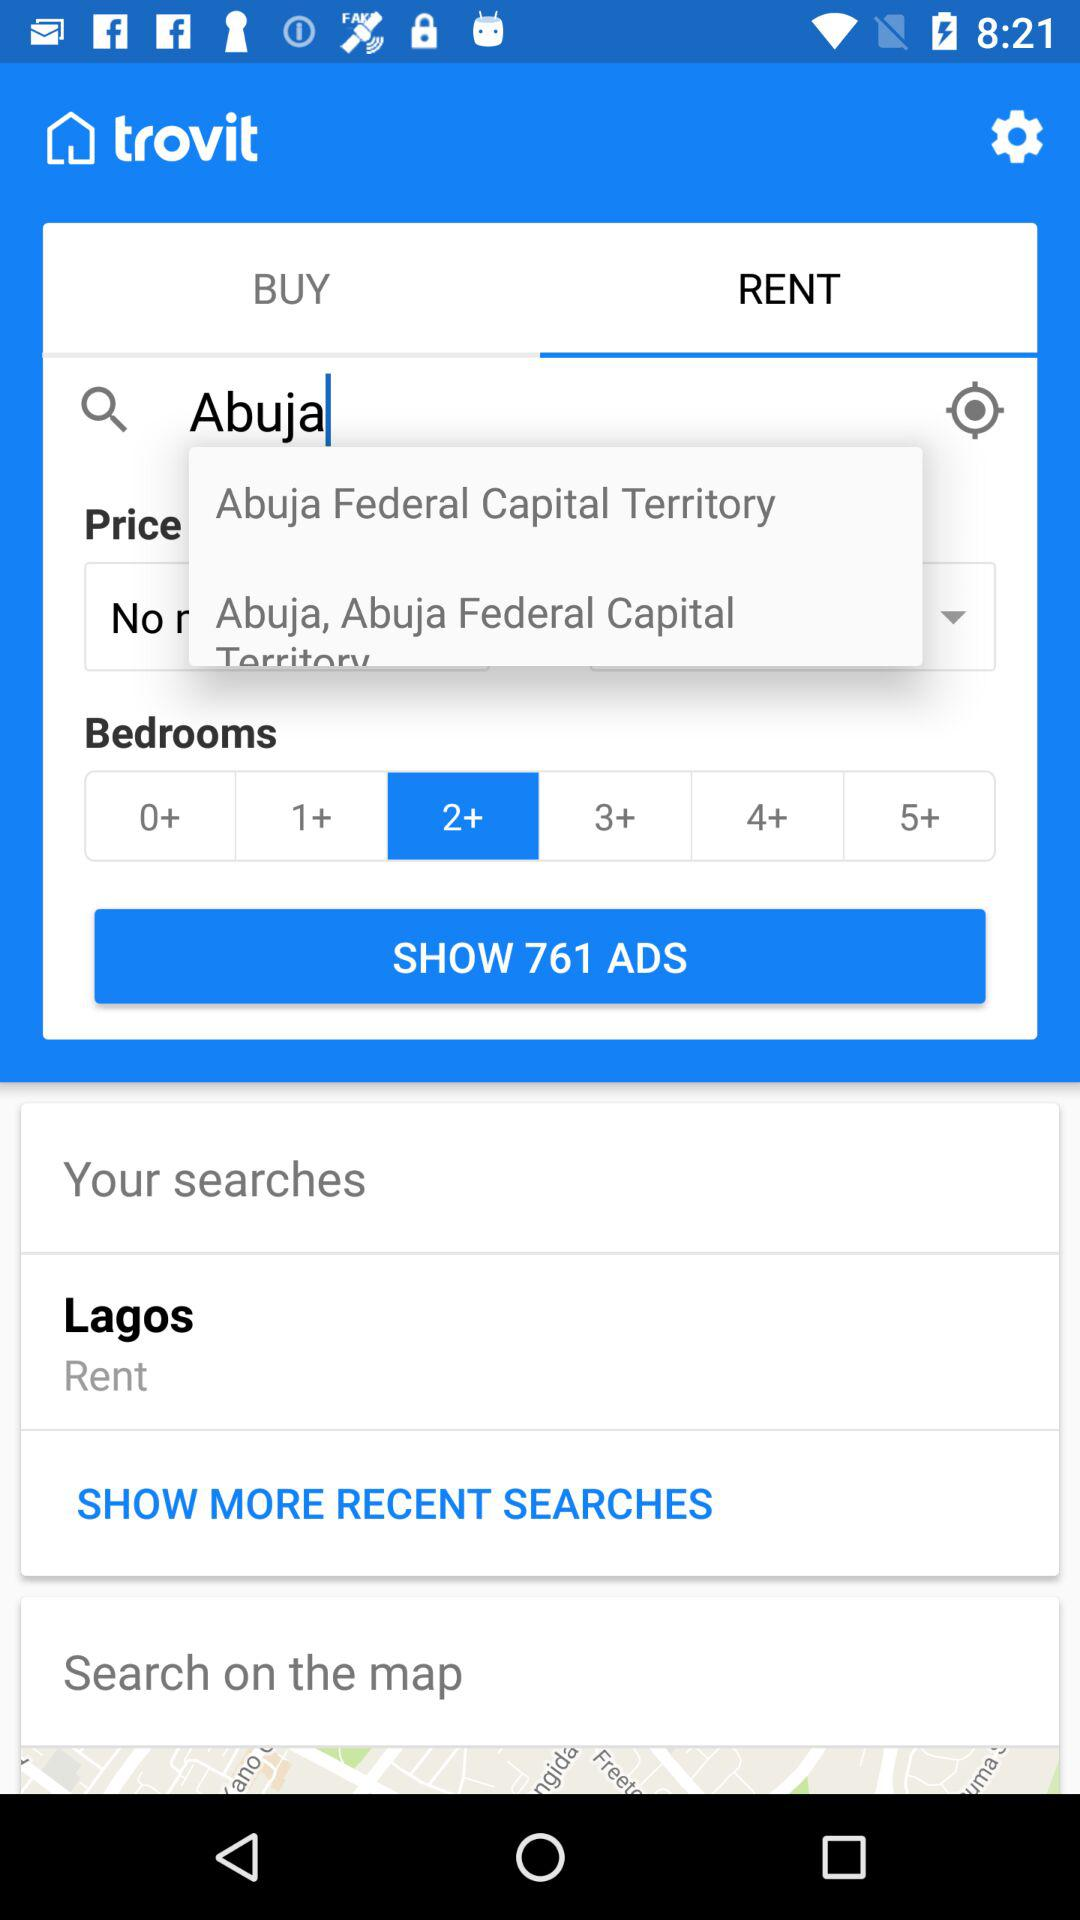What is the name of the application? The name of the application is "trovit". 